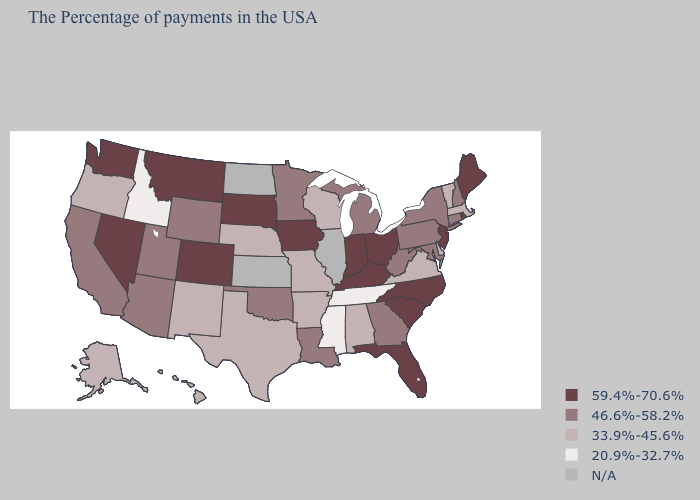What is the value of Nebraska?
Quick response, please. 33.9%-45.6%. Name the states that have a value in the range 59.4%-70.6%?
Write a very short answer. Maine, Rhode Island, New Jersey, North Carolina, South Carolina, Ohio, Florida, Kentucky, Indiana, Iowa, South Dakota, Colorado, Montana, Nevada, Washington. Which states have the highest value in the USA?
Quick response, please. Maine, Rhode Island, New Jersey, North Carolina, South Carolina, Ohio, Florida, Kentucky, Indiana, Iowa, South Dakota, Colorado, Montana, Nevada, Washington. What is the value of Mississippi?
Give a very brief answer. 20.9%-32.7%. Name the states that have a value in the range 33.9%-45.6%?
Answer briefly. Massachusetts, Vermont, Delaware, Virginia, Alabama, Wisconsin, Missouri, Arkansas, Nebraska, Texas, New Mexico, Oregon, Alaska, Hawaii. Which states have the highest value in the USA?
Write a very short answer. Maine, Rhode Island, New Jersey, North Carolina, South Carolina, Ohio, Florida, Kentucky, Indiana, Iowa, South Dakota, Colorado, Montana, Nevada, Washington. What is the value of Massachusetts?
Write a very short answer. 33.9%-45.6%. Does the map have missing data?
Write a very short answer. Yes. What is the value of Virginia?
Keep it brief. 33.9%-45.6%. Does the first symbol in the legend represent the smallest category?
Short answer required. No. Does Oklahoma have the lowest value in the South?
Keep it brief. No. What is the highest value in the Northeast ?
Give a very brief answer. 59.4%-70.6%. What is the value of Nebraska?
Quick response, please. 33.9%-45.6%. Name the states that have a value in the range N/A?
Quick response, please. Illinois, Kansas, North Dakota. 